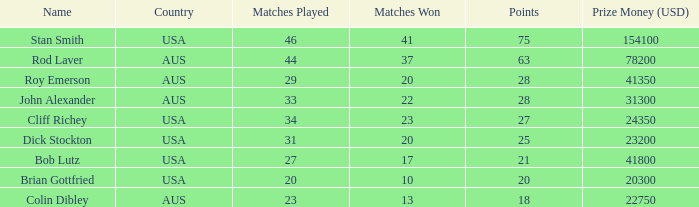In how many games did colin dibley achieve victory? 13.0. 